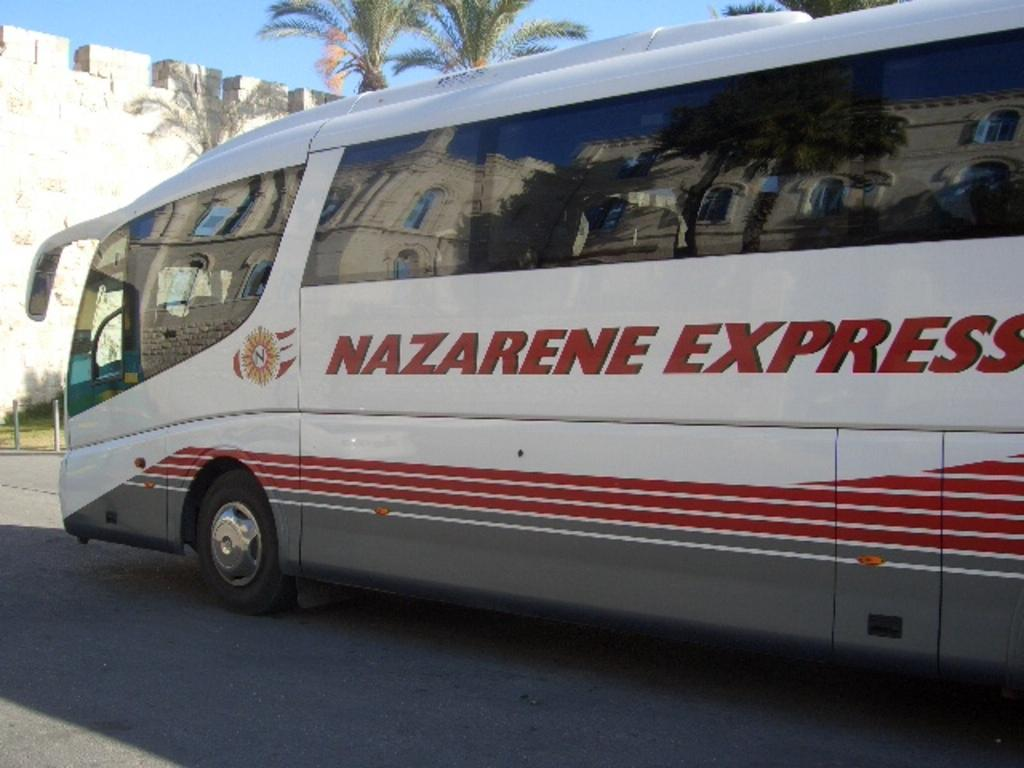Provide a one-sentence caption for the provided image. A white bus that says Nazarene Express on the side of it. 